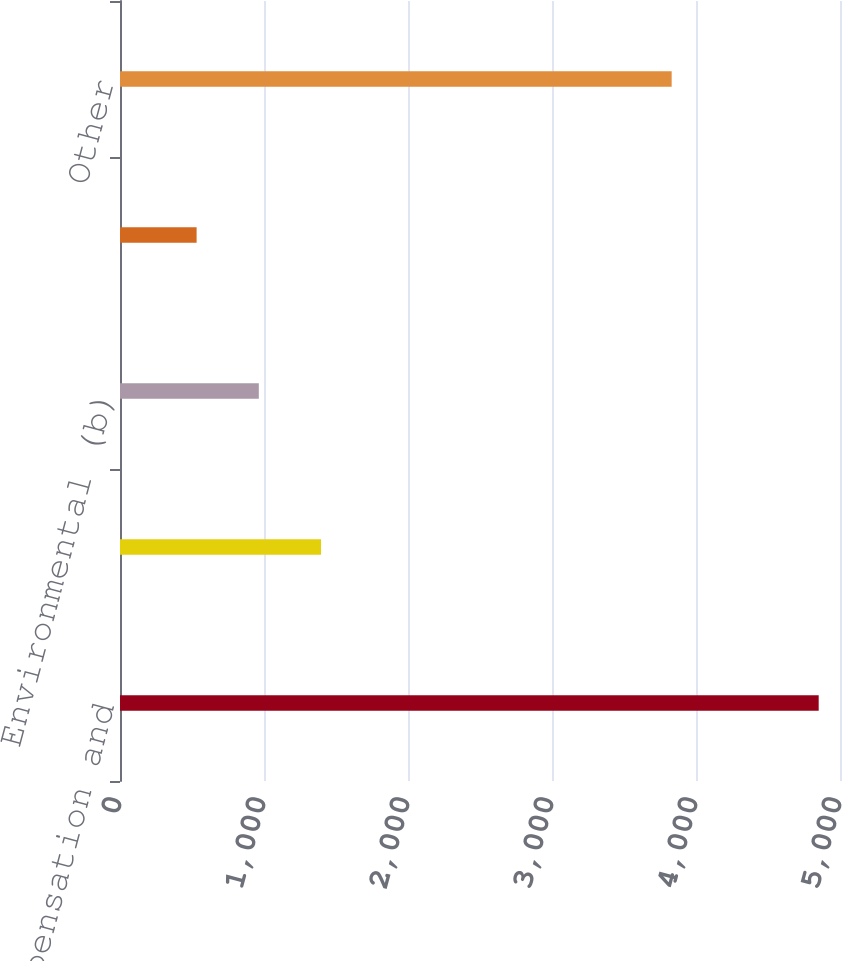Convert chart. <chart><loc_0><loc_0><loc_500><loc_500><bar_chart><fcel>Accrued compensation and<fcel>Product warranties (a)<fcel>Environmental (b)<fcel>Forward loss recognition (c)<fcel>Other<nl><fcel>4852<fcel>1396<fcel>964<fcel>532<fcel>3831<nl></chart> 